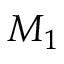<formula> <loc_0><loc_0><loc_500><loc_500>M _ { 1 }</formula> 